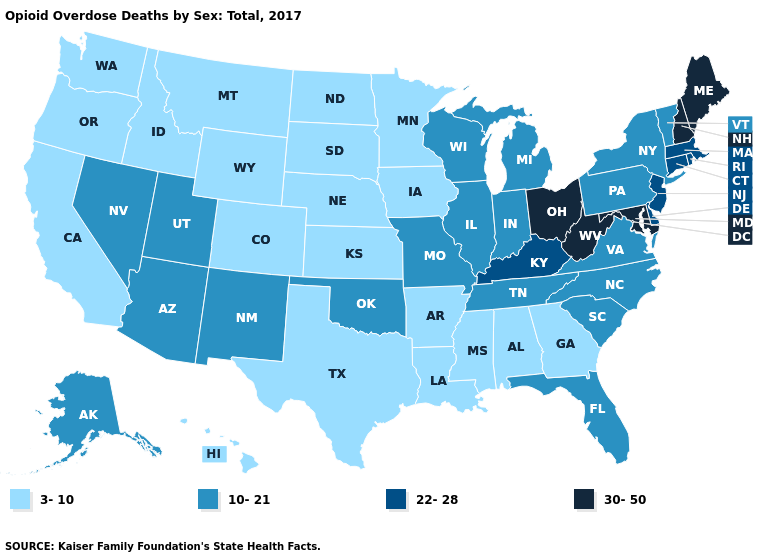What is the value of Idaho?
Short answer required. 3-10. What is the lowest value in the USA?
Concise answer only. 3-10. Among the states that border Wisconsin , which have the highest value?
Short answer required. Illinois, Michigan. What is the highest value in the West ?
Answer briefly. 10-21. What is the value of Kansas?
Quick response, please. 3-10. Name the states that have a value in the range 10-21?
Quick response, please. Alaska, Arizona, Florida, Illinois, Indiana, Michigan, Missouri, Nevada, New Mexico, New York, North Carolina, Oklahoma, Pennsylvania, South Carolina, Tennessee, Utah, Vermont, Virginia, Wisconsin. Does the map have missing data?
Short answer required. No. Does Missouri have the same value as Michigan?
Short answer required. Yes. Name the states that have a value in the range 30-50?
Give a very brief answer. Maine, Maryland, New Hampshire, Ohio, West Virginia. What is the highest value in the South ?
Short answer required. 30-50. Which states have the lowest value in the MidWest?
Answer briefly. Iowa, Kansas, Minnesota, Nebraska, North Dakota, South Dakota. Does Maryland have the same value as Maine?
Answer briefly. Yes. What is the lowest value in states that border Virginia?
Give a very brief answer. 10-21. Name the states that have a value in the range 30-50?
Short answer required. Maine, Maryland, New Hampshire, Ohio, West Virginia. Does the map have missing data?
Answer briefly. No. 